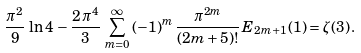<formula> <loc_0><loc_0><loc_500><loc_500>\frac { \pi ^ { 2 } } { 9 } \, \ln { 4 } \, - \frac { 2 \, \pi ^ { 4 } } { 3 } \, \sum _ { m = 0 } ^ { \infty } { ( - 1 ) ^ { m } \, \frac { \pi ^ { 2 m } } { ( 2 m + 5 ) ! } \, E _ { 2 m + 1 } ( 1 ) } = \zeta ( 3 ) \, .</formula> 